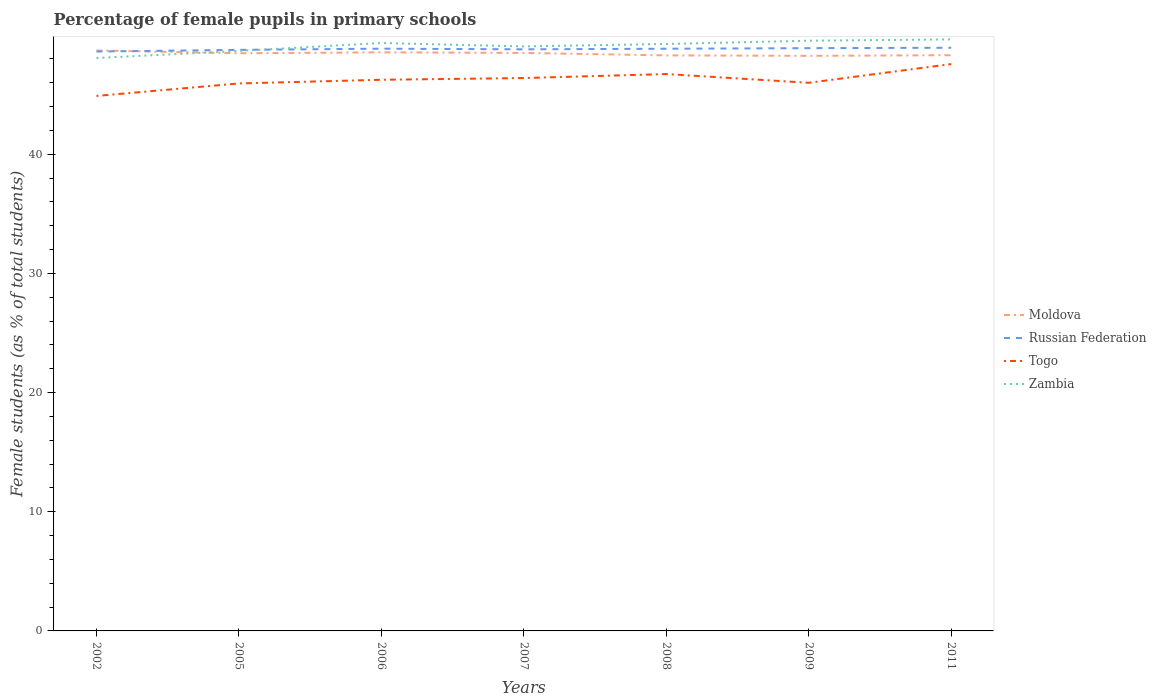Is the number of lines equal to the number of legend labels?
Your answer should be very brief. Yes. Across all years, what is the maximum percentage of female pupils in primary schools in Russian Federation?
Provide a short and direct response. 48.62. What is the total percentage of female pupils in primary schools in Togo in the graph?
Your response must be concise. -1.57. What is the difference between the highest and the second highest percentage of female pupils in primary schools in Zambia?
Ensure brevity in your answer.  1.56. What is the difference between the highest and the lowest percentage of female pupils in primary schools in Zambia?
Ensure brevity in your answer.  4. Is the percentage of female pupils in primary schools in Moldova strictly greater than the percentage of female pupils in primary schools in Russian Federation over the years?
Provide a succinct answer. No. How many years are there in the graph?
Make the answer very short. 7. What is the difference between two consecutive major ticks on the Y-axis?
Provide a succinct answer. 10. Are the values on the major ticks of Y-axis written in scientific E-notation?
Offer a very short reply. No. Does the graph contain any zero values?
Offer a very short reply. No. Does the graph contain grids?
Your answer should be compact. No. Where does the legend appear in the graph?
Keep it short and to the point. Center right. How many legend labels are there?
Your answer should be very brief. 4. What is the title of the graph?
Ensure brevity in your answer.  Percentage of female pupils in primary schools. What is the label or title of the X-axis?
Provide a succinct answer. Years. What is the label or title of the Y-axis?
Your answer should be compact. Female students (as % of total students). What is the Female students (as % of total students) in Moldova in 2002?
Keep it short and to the point. 48.71. What is the Female students (as % of total students) of Russian Federation in 2002?
Provide a short and direct response. 48.62. What is the Female students (as % of total students) in Togo in 2002?
Offer a terse response. 44.89. What is the Female students (as % of total students) of Zambia in 2002?
Give a very brief answer. 48.08. What is the Female students (as % of total students) of Moldova in 2005?
Keep it short and to the point. 48.48. What is the Female students (as % of total students) in Russian Federation in 2005?
Offer a very short reply. 48.76. What is the Female students (as % of total students) of Togo in 2005?
Keep it short and to the point. 45.94. What is the Female students (as % of total students) in Zambia in 2005?
Keep it short and to the point. 48.67. What is the Female students (as % of total students) of Moldova in 2006?
Keep it short and to the point. 48.55. What is the Female students (as % of total students) of Russian Federation in 2006?
Your answer should be compact. 48.86. What is the Female students (as % of total students) of Togo in 2006?
Make the answer very short. 46.25. What is the Female students (as % of total students) in Zambia in 2006?
Your answer should be compact. 49.34. What is the Female students (as % of total students) of Moldova in 2007?
Your answer should be very brief. 48.5. What is the Female students (as % of total students) in Russian Federation in 2007?
Make the answer very short. 48.81. What is the Female students (as % of total students) of Togo in 2007?
Give a very brief answer. 46.4. What is the Female students (as % of total students) in Zambia in 2007?
Your answer should be compact. 49.05. What is the Female students (as % of total students) in Moldova in 2008?
Give a very brief answer. 48.3. What is the Female students (as % of total students) of Russian Federation in 2008?
Ensure brevity in your answer.  48.86. What is the Female students (as % of total students) in Togo in 2008?
Your response must be concise. 46.73. What is the Female students (as % of total students) of Zambia in 2008?
Offer a very short reply. 49.25. What is the Female students (as % of total students) of Moldova in 2009?
Give a very brief answer. 48.26. What is the Female students (as % of total students) of Russian Federation in 2009?
Provide a short and direct response. 48.9. What is the Female students (as % of total students) in Togo in 2009?
Offer a terse response. 46. What is the Female students (as % of total students) of Zambia in 2009?
Your answer should be compact. 49.53. What is the Female students (as % of total students) in Moldova in 2011?
Your response must be concise. 48.31. What is the Female students (as % of total students) of Russian Federation in 2011?
Your answer should be very brief. 48.94. What is the Female students (as % of total students) of Togo in 2011?
Your answer should be very brief. 47.57. What is the Female students (as % of total students) in Zambia in 2011?
Keep it short and to the point. 49.64. Across all years, what is the maximum Female students (as % of total students) in Moldova?
Give a very brief answer. 48.71. Across all years, what is the maximum Female students (as % of total students) in Russian Federation?
Your response must be concise. 48.94. Across all years, what is the maximum Female students (as % of total students) of Togo?
Keep it short and to the point. 47.57. Across all years, what is the maximum Female students (as % of total students) of Zambia?
Your answer should be very brief. 49.64. Across all years, what is the minimum Female students (as % of total students) in Moldova?
Your answer should be very brief. 48.26. Across all years, what is the minimum Female students (as % of total students) of Russian Federation?
Provide a short and direct response. 48.62. Across all years, what is the minimum Female students (as % of total students) of Togo?
Give a very brief answer. 44.89. Across all years, what is the minimum Female students (as % of total students) of Zambia?
Provide a short and direct response. 48.08. What is the total Female students (as % of total students) in Moldova in the graph?
Offer a terse response. 339.11. What is the total Female students (as % of total students) of Russian Federation in the graph?
Your response must be concise. 341.75. What is the total Female students (as % of total students) in Togo in the graph?
Make the answer very short. 323.78. What is the total Female students (as % of total students) of Zambia in the graph?
Your answer should be very brief. 343.56. What is the difference between the Female students (as % of total students) of Moldova in 2002 and that in 2005?
Ensure brevity in your answer.  0.23. What is the difference between the Female students (as % of total students) in Russian Federation in 2002 and that in 2005?
Your response must be concise. -0.14. What is the difference between the Female students (as % of total students) of Togo in 2002 and that in 2005?
Offer a very short reply. -1.05. What is the difference between the Female students (as % of total students) in Zambia in 2002 and that in 2005?
Provide a short and direct response. -0.59. What is the difference between the Female students (as % of total students) of Moldova in 2002 and that in 2006?
Offer a very short reply. 0.16. What is the difference between the Female students (as % of total students) of Russian Federation in 2002 and that in 2006?
Keep it short and to the point. -0.24. What is the difference between the Female students (as % of total students) in Togo in 2002 and that in 2006?
Your answer should be very brief. -1.36. What is the difference between the Female students (as % of total students) of Zambia in 2002 and that in 2006?
Your answer should be compact. -1.26. What is the difference between the Female students (as % of total students) of Moldova in 2002 and that in 2007?
Offer a very short reply. 0.2. What is the difference between the Female students (as % of total students) of Russian Federation in 2002 and that in 2007?
Your answer should be very brief. -0.18. What is the difference between the Female students (as % of total students) of Togo in 2002 and that in 2007?
Your answer should be very brief. -1.5. What is the difference between the Female students (as % of total students) in Zambia in 2002 and that in 2007?
Give a very brief answer. -0.97. What is the difference between the Female students (as % of total students) of Moldova in 2002 and that in 2008?
Provide a short and direct response. 0.41. What is the difference between the Female students (as % of total students) of Russian Federation in 2002 and that in 2008?
Make the answer very short. -0.23. What is the difference between the Female students (as % of total students) of Togo in 2002 and that in 2008?
Offer a terse response. -1.84. What is the difference between the Female students (as % of total students) of Zambia in 2002 and that in 2008?
Ensure brevity in your answer.  -1.18. What is the difference between the Female students (as % of total students) in Moldova in 2002 and that in 2009?
Your answer should be compact. 0.45. What is the difference between the Female students (as % of total students) in Russian Federation in 2002 and that in 2009?
Ensure brevity in your answer.  -0.28. What is the difference between the Female students (as % of total students) of Togo in 2002 and that in 2009?
Provide a succinct answer. -1.1. What is the difference between the Female students (as % of total students) in Zambia in 2002 and that in 2009?
Your response must be concise. -1.45. What is the difference between the Female students (as % of total students) in Moldova in 2002 and that in 2011?
Offer a very short reply. 0.4. What is the difference between the Female students (as % of total students) of Russian Federation in 2002 and that in 2011?
Keep it short and to the point. -0.32. What is the difference between the Female students (as % of total students) in Togo in 2002 and that in 2011?
Keep it short and to the point. -2.68. What is the difference between the Female students (as % of total students) of Zambia in 2002 and that in 2011?
Your response must be concise. -1.56. What is the difference between the Female students (as % of total students) in Moldova in 2005 and that in 2006?
Ensure brevity in your answer.  -0.08. What is the difference between the Female students (as % of total students) of Russian Federation in 2005 and that in 2006?
Give a very brief answer. -0.1. What is the difference between the Female students (as % of total students) of Togo in 2005 and that in 2006?
Ensure brevity in your answer.  -0.31. What is the difference between the Female students (as % of total students) of Zambia in 2005 and that in 2006?
Your answer should be compact. -0.67. What is the difference between the Female students (as % of total students) of Moldova in 2005 and that in 2007?
Provide a succinct answer. -0.03. What is the difference between the Female students (as % of total students) of Russian Federation in 2005 and that in 2007?
Your answer should be very brief. -0.05. What is the difference between the Female students (as % of total students) of Togo in 2005 and that in 2007?
Keep it short and to the point. -0.45. What is the difference between the Female students (as % of total students) of Zambia in 2005 and that in 2007?
Your answer should be very brief. -0.38. What is the difference between the Female students (as % of total students) in Moldova in 2005 and that in 2008?
Keep it short and to the point. 0.18. What is the difference between the Female students (as % of total students) in Russian Federation in 2005 and that in 2008?
Keep it short and to the point. -0.1. What is the difference between the Female students (as % of total students) of Togo in 2005 and that in 2008?
Offer a terse response. -0.79. What is the difference between the Female students (as % of total students) in Zambia in 2005 and that in 2008?
Give a very brief answer. -0.58. What is the difference between the Female students (as % of total students) of Moldova in 2005 and that in 2009?
Give a very brief answer. 0.22. What is the difference between the Female students (as % of total students) in Russian Federation in 2005 and that in 2009?
Make the answer very short. -0.14. What is the difference between the Female students (as % of total students) in Togo in 2005 and that in 2009?
Your response must be concise. -0.06. What is the difference between the Female students (as % of total students) in Zambia in 2005 and that in 2009?
Give a very brief answer. -0.86. What is the difference between the Female students (as % of total students) of Moldova in 2005 and that in 2011?
Your answer should be compact. 0.16. What is the difference between the Female students (as % of total students) in Russian Federation in 2005 and that in 2011?
Offer a very short reply. -0.18. What is the difference between the Female students (as % of total students) of Togo in 2005 and that in 2011?
Your answer should be compact. -1.63. What is the difference between the Female students (as % of total students) in Zambia in 2005 and that in 2011?
Your response must be concise. -0.97. What is the difference between the Female students (as % of total students) in Moldova in 2006 and that in 2007?
Make the answer very short. 0.05. What is the difference between the Female students (as % of total students) of Russian Federation in 2006 and that in 2007?
Keep it short and to the point. 0.06. What is the difference between the Female students (as % of total students) of Togo in 2006 and that in 2007?
Your answer should be compact. -0.14. What is the difference between the Female students (as % of total students) of Zambia in 2006 and that in 2007?
Your response must be concise. 0.29. What is the difference between the Female students (as % of total students) of Moldova in 2006 and that in 2008?
Your answer should be compact. 0.25. What is the difference between the Female students (as % of total students) of Russian Federation in 2006 and that in 2008?
Your answer should be compact. 0.01. What is the difference between the Female students (as % of total students) in Togo in 2006 and that in 2008?
Your answer should be very brief. -0.48. What is the difference between the Female students (as % of total students) of Zambia in 2006 and that in 2008?
Provide a short and direct response. 0.08. What is the difference between the Female students (as % of total students) in Moldova in 2006 and that in 2009?
Offer a very short reply. 0.29. What is the difference between the Female students (as % of total students) in Russian Federation in 2006 and that in 2009?
Make the answer very short. -0.04. What is the difference between the Female students (as % of total students) of Togo in 2006 and that in 2009?
Provide a short and direct response. 0.25. What is the difference between the Female students (as % of total students) of Zambia in 2006 and that in 2009?
Ensure brevity in your answer.  -0.19. What is the difference between the Female students (as % of total students) in Moldova in 2006 and that in 2011?
Make the answer very short. 0.24. What is the difference between the Female students (as % of total students) of Russian Federation in 2006 and that in 2011?
Keep it short and to the point. -0.08. What is the difference between the Female students (as % of total students) of Togo in 2006 and that in 2011?
Your response must be concise. -1.32. What is the difference between the Female students (as % of total students) in Zambia in 2006 and that in 2011?
Offer a very short reply. -0.3. What is the difference between the Female students (as % of total students) in Moldova in 2007 and that in 2008?
Offer a terse response. 0.21. What is the difference between the Female students (as % of total students) in Russian Federation in 2007 and that in 2008?
Offer a terse response. -0.05. What is the difference between the Female students (as % of total students) of Togo in 2007 and that in 2008?
Give a very brief answer. -0.33. What is the difference between the Female students (as % of total students) of Zambia in 2007 and that in 2008?
Provide a short and direct response. -0.2. What is the difference between the Female students (as % of total students) in Moldova in 2007 and that in 2009?
Provide a succinct answer. 0.24. What is the difference between the Female students (as % of total students) in Russian Federation in 2007 and that in 2009?
Give a very brief answer. -0.1. What is the difference between the Female students (as % of total students) of Togo in 2007 and that in 2009?
Keep it short and to the point. 0.4. What is the difference between the Female students (as % of total students) of Zambia in 2007 and that in 2009?
Give a very brief answer. -0.48. What is the difference between the Female students (as % of total students) of Moldova in 2007 and that in 2011?
Your answer should be compact. 0.19. What is the difference between the Female students (as % of total students) of Russian Federation in 2007 and that in 2011?
Provide a short and direct response. -0.13. What is the difference between the Female students (as % of total students) of Togo in 2007 and that in 2011?
Your answer should be compact. -1.17. What is the difference between the Female students (as % of total students) of Zambia in 2007 and that in 2011?
Provide a succinct answer. -0.59. What is the difference between the Female students (as % of total students) of Moldova in 2008 and that in 2009?
Provide a short and direct response. 0.04. What is the difference between the Female students (as % of total students) in Russian Federation in 2008 and that in 2009?
Your answer should be compact. -0.05. What is the difference between the Female students (as % of total students) of Togo in 2008 and that in 2009?
Provide a succinct answer. 0.73. What is the difference between the Female students (as % of total students) in Zambia in 2008 and that in 2009?
Provide a short and direct response. -0.28. What is the difference between the Female students (as % of total students) of Moldova in 2008 and that in 2011?
Ensure brevity in your answer.  -0.01. What is the difference between the Female students (as % of total students) in Russian Federation in 2008 and that in 2011?
Your answer should be very brief. -0.08. What is the difference between the Female students (as % of total students) of Togo in 2008 and that in 2011?
Give a very brief answer. -0.84. What is the difference between the Female students (as % of total students) of Zambia in 2008 and that in 2011?
Offer a very short reply. -0.39. What is the difference between the Female students (as % of total students) in Moldova in 2009 and that in 2011?
Your answer should be very brief. -0.05. What is the difference between the Female students (as % of total students) in Russian Federation in 2009 and that in 2011?
Offer a very short reply. -0.03. What is the difference between the Female students (as % of total students) of Togo in 2009 and that in 2011?
Ensure brevity in your answer.  -1.57. What is the difference between the Female students (as % of total students) in Zambia in 2009 and that in 2011?
Provide a short and direct response. -0.11. What is the difference between the Female students (as % of total students) in Moldova in 2002 and the Female students (as % of total students) in Russian Federation in 2005?
Make the answer very short. -0.05. What is the difference between the Female students (as % of total students) of Moldova in 2002 and the Female students (as % of total students) of Togo in 2005?
Ensure brevity in your answer.  2.77. What is the difference between the Female students (as % of total students) of Moldova in 2002 and the Female students (as % of total students) of Zambia in 2005?
Ensure brevity in your answer.  0.04. What is the difference between the Female students (as % of total students) of Russian Federation in 2002 and the Female students (as % of total students) of Togo in 2005?
Ensure brevity in your answer.  2.68. What is the difference between the Female students (as % of total students) in Russian Federation in 2002 and the Female students (as % of total students) in Zambia in 2005?
Provide a succinct answer. -0.05. What is the difference between the Female students (as % of total students) of Togo in 2002 and the Female students (as % of total students) of Zambia in 2005?
Make the answer very short. -3.78. What is the difference between the Female students (as % of total students) in Moldova in 2002 and the Female students (as % of total students) in Russian Federation in 2006?
Your answer should be compact. -0.15. What is the difference between the Female students (as % of total students) of Moldova in 2002 and the Female students (as % of total students) of Togo in 2006?
Your answer should be compact. 2.46. What is the difference between the Female students (as % of total students) in Moldova in 2002 and the Female students (as % of total students) in Zambia in 2006?
Provide a short and direct response. -0.63. What is the difference between the Female students (as % of total students) of Russian Federation in 2002 and the Female students (as % of total students) of Togo in 2006?
Make the answer very short. 2.37. What is the difference between the Female students (as % of total students) in Russian Federation in 2002 and the Female students (as % of total students) in Zambia in 2006?
Give a very brief answer. -0.72. What is the difference between the Female students (as % of total students) in Togo in 2002 and the Female students (as % of total students) in Zambia in 2006?
Ensure brevity in your answer.  -4.44. What is the difference between the Female students (as % of total students) of Moldova in 2002 and the Female students (as % of total students) of Russian Federation in 2007?
Provide a short and direct response. -0.1. What is the difference between the Female students (as % of total students) of Moldova in 2002 and the Female students (as % of total students) of Togo in 2007?
Provide a succinct answer. 2.31. What is the difference between the Female students (as % of total students) in Moldova in 2002 and the Female students (as % of total students) in Zambia in 2007?
Your answer should be very brief. -0.34. What is the difference between the Female students (as % of total students) of Russian Federation in 2002 and the Female students (as % of total students) of Togo in 2007?
Your response must be concise. 2.23. What is the difference between the Female students (as % of total students) of Russian Federation in 2002 and the Female students (as % of total students) of Zambia in 2007?
Give a very brief answer. -0.43. What is the difference between the Female students (as % of total students) of Togo in 2002 and the Female students (as % of total students) of Zambia in 2007?
Give a very brief answer. -4.16. What is the difference between the Female students (as % of total students) in Moldova in 2002 and the Female students (as % of total students) in Russian Federation in 2008?
Your answer should be compact. -0.15. What is the difference between the Female students (as % of total students) in Moldova in 2002 and the Female students (as % of total students) in Togo in 2008?
Your answer should be very brief. 1.98. What is the difference between the Female students (as % of total students) in Moldova in 2002 and the Female students (as % of total students) in Zambia in 2008?
Offer a very short reply. -0.54. What is the difference between the Female students (as % of total students) in Russian Federation in 2002 and the Female students (as % of total students) in Togo in 2008?
Give a very brief answer. 1.89. What is the difference between the Female students (as % of total students) in Russian Federation in 2002 and the Female students (as % of total students) in Zambia in 2008?
Offer a terse response. -0.63. What is the difference between the Female students (as % of total students) in Togo in 2002 and the Female students (as % of total students) in Zambia in 2008?
Offer a terse response. -4.36. What is the difference between the Female students (as % of total students) of Moldova in 2002 and the Female students (as % of total students) of Russian Federation in 2009?
Make the answer very short. -0.2. What is the difference between the Female students (as % of total students) of Moldova in 2002 and the Female students (as % of total students) of Togo in 2009?
Provide a short and direct response. 2.71. What is the difference between the Female students (as % of total students) in Moldova in 2002 and the Female students (as % of total students) in Zambia in 2009?
Offer a terse response. -0.82. What is the difference between the Female students (as % of total students) in Russian Federation in 2002 and the Female students (as % of total students) in Togo in 2009?
Ensure brevity in your answer.  2.62. What is the difference between the Female students (as % of total students) in Russian Federation in 2002 and the Female students (as % of total students) in Zambia in 2009?
Make the answer very short. -0.91. What is the difference between the Female students (as % of total students) in Togo in 2002 and the Female students (as % of total students) in Zambia in 2009?
Offer a terse response. -4.64. What is the difference between the Female students (as % of total students) of Moldova in 2002 and the Female students (as % of total students) of Russian Federation in 2011?
Keep it short and to the point. -0.23. What is the difference between the Female students (as % of total students) of Moldova in 2002 and the Female students (as % of total students) of Togo in 2011?
Make the answer very short. 1.14. What is the difference between the Female students (as % of total students) in Moldova in 2002 and the Female students (as % of total students) in Zambia in 2011?
Ensure brevity in your answer.  -0.93. What is the difference between the Female students (as % of total students) in Russian Federation in 2002 and the Female students (as % of total students) in Togo in 2011?
Your response must be concise. 1.05. What is the difference between the Female students (as % of total students) in Russian Federation in 2002 and the Female students (as % of total students) in Zambia in 2011?
Your answer should be very brief. -1.02. What is the difference between the Female students (as % of total students) in Togo in 2002 and the Female students (as % of total students) in Zambia in 2011?
Provide a succinct answer. -4.75. What is the difference between the Female students (as % of total students) in Moldova in 2005 and the Female students (as % of total students) in Russian Federation in 2006?
Provide a succinct answer. -0.39. What is the difference between the Female students (as % of total students) of Moldova in 2005 and the Female students (as % of total students) of Togo in 2006?
Provide a succinct answer. 2.22. What is the difference between the Female students (as % of total students) in Moldova in 2005 and the Female students (as % of total students) in Zambia in 2006?
Provide a succinct answer. -0.86. What is the difference between the Female students (as % of total students) of Russian Federation in 2005 and the Female students (as % of total students) of Togo in 2006?
Your answer should be compact. 2.51. What is the difference between the Female students (as % of total students) in Russian Federation in 2005 and the Female students (as % of total students) in Zambia in 2006?
Give a very brief answer. -0.58. What is the difference between the Female students (as % of total students) in Togo in 2005 and the Female students (as % of total students) in Zambia in 2006?
Provide a succinct answer. -3.39. What is the difference between the Female students (as % of total students) in Moldova in 2005 and the Female students (as % of total students) in Russian Federation in 2007?
Offer a very short reply. -0.33. What is the difference between the Female students (as % of total students) of Moldova in 2005 and the Female students (as % of total students) of Togo in 2007?
Provide a short and direct response. 2.08. What is the difference between the Female students (as % of total students) in Moldova in 2005 and the Female students (as % of total students) in Zambia in 2007?
Your answer should be compact. -0.57. What is the difference between the Female students (as % of total students) of Russian Federation in 2005 and the Female students (as % of total students) of Togo in 2007?
Give a very brief answer. 2.36. What is the difference between the Female students (as % of total students) in Russian Federation in 2005 and the Female students (as % of total students) in Zambia in 2007?
Provide a succinct answer. -0.29. What is the difference between the Female students (as % of total students) in Togo in 2005 and the Female students (as % of total students) in Zambia in 2007?
Give a very brief answer. -3.11. What is the difference between the Female students (as % of total students) in Moldova in 2005 and the Female students (as % of total students) in Russian Federation in 2008?
Give a very brief answer. -0.38. What is the difference between the Female students (as % of total students) of Moldova in 2005 and the Female students (as % of total students) of Togo in 2008?
Your answer should be compact. 1.75. What is the difference between the Female students (as % of total students) of Moldova in 2005 and the Female students (as % of total students) of Zambia in 2008?
Make the answer very short. -0.78. What is the difference between the Female students (as % of total students) in Russian Federation in 2005 and the Female students (as % of total students) in Togo in 2008?
Offer a very short reply. 2.03. What is the difference between the Female students (as % of total students) in Russian Federation in 2005 and the Female students (as % of total students) in Zambia in 2008?
Offer a terse response. -0.49. What is the difference between the Female students (as % of total students) in Togo in 2005 and the Female students (as % of total students) in Zambia in 2008?
Give a very brief answer. -3.31. What is the difference between the Female students (as % of total students) in Moldova in 2005 and the Female students (as % of total students) in Russian Federation in 2009?
Your answer should be very brief. -0.43. What is the difference between the Female students (as % of total students) in Moldova in 2005 and the Female students (as % of total students) in Togo in 2009?
Ensure brevity in your answer.  2.48. What is the difference between the Female students (as % of total students) in Moldova in 2005 and the Female students (as % of total students) in Zambia in 2009?
Your answer should be very brief. -1.05. What is the difference between the Female students (as % of total students) of Russian Federation in 2005 and the Female students (as % of total students) of Togo in 2009?
Make the answer very short. 2.76. What is the difference between the Female students (as % of total students) of Russian Federation in 2005 and the Female students (as % of total students) of Zambia in 2009?
Offer a very short reply. -0.77. What is the difference between the Female students (as % of total students) in Togo in 2005 and the Female students (as % of total students) in Zambia in 2009?
Offer a very short reply. -3.59. What is the difference between the Female students (as % of total students) in Moldova in 2005 and the Female students (as % of total students) in Russian Federation in 2011?
Your answer should be compact. -0.46. What is the difference between the Female students (as % of total students) in Moldova in 2005 and the Female students (as % of total students) in Togo in 2011?
Provide a succinct answer. 0.91. What is the difference between the Female students (as % of total students) in Moldova in 2005 and the Female students (as % of total students) in Zambia in 2011?
Keep it short and to the point. -1.16. What is the difference between the Female students (as % of total students) in Russian Federation in 2005 and the Female students (as % of total students) in Togo in 2011?
Keep it short and to the point. 1.19. What is the difference between the Female students (as % of total students) in Russian Federation in 2005 and the Female students (as % of total students) in Zambia in 2011?
Your answer should be very brief. -0.88. What is the difference between the Female students (as % of total students) of Togo in 2005 and the Female students (as % of total students) of Zambia in 2011?
Offer a very short reply. -3.7. What is the difference between the Female students (as % of total students) of Moldova in 2006 and the Female students (as % of total students) of Russian Federation in 2007?
Keep it short and to the point. -0.25. What is the difference between the Female students (as % of total students) of Moldova in 2006 and the Female students (as % of total students) of Togo in 2007?
Your answer should be compact. 2.16. What is the difference between the Female students (as % of total students) of Moldova in 2006 and the Female students (as % of total students) of Zambia in 2007?
Ensure brevity in your answer.  -0.5. What is the difference between the Female students (as % of total students) of Russian Federation in 2006 and the Female students (as % of total students) of Togo in 2007?
Provide a short and direct response. 2.47. What is the difference between the Female students (as % of total students) of Russian Federation in 2006 and the Female students (as % of total students) of Zambia in 2007?
Offer a terse response. -0.19. What is the difference between the Female students (as % of total students) of Togo in 2006 and the Female students (as % of total students) of Zambia in 2007?
Make the answer very short. -2.8. What is the difference between the Female students (as % of total students) of Moldova in 2006 and the Female students (as % of total students) of Russian Federation in 2008?
Provide a short and direct response. -0.3. What is the difference between the Female students (as % of total students) in Moldova in 2006 and the Female students (as % of total students) in Togo in 2008?
Provide a short and direct response. 1.82. What is the difference between the Female students (as % of total students) in Moldova in 2006 and the Female students (as % of total students) in Zambia in 2008?
Keep it short and to the point. -0.7. What is the difference between the Female students (as % of total students) of Russian Federation in 2006 and the Female students (as % of total students) of Togo in 2008?
Give a very brief answer. 2.13. What is the difference between the Female students (as % of total students) in Russian Federation in 2006 and the Female students (as % of total students) in Zambia in 2008?
Keep it short and to the point. -0.39. What is the difference between the Female students (as % of total students) of Togo in 2006 and the Female students (as % of total students) of Zambia in 2008?
Your answer should be compact. -3. What is the difference between the Female students (as % of total students) in Moldova in 2006 and the Female students (as % of total students) in Russian Federation in 2009?
Keep it short and to the point. -0.35. What is the difference between the Female students (as % of total students) of Moldova in 2006 and the Female students (as % of total students) of Togo in 2009?
Your answer should be compact. 2.55. What is the difference between the Female students (as % of total students) in Moldova in 2006 and the Female students (as % of total students) in Zambia in 2009?
Offer a very short reply. -0.98. What is the difference between the Female students (as % of total students) in Russian Federation in 2006 and the Female students (as % of total students) in Togo in 2009?
Provide a succinct answer. 2.86. What is the difference between the Female students (as % of total students) in Russian Federation in 2006 and the Female students (as % of total students) in Zambia in 2009?
Provide a short and direct response. -0.67. What is the difference between the Female students (as % of total students) of Togo in 2006 and the Female students (as % of total students) of Zambia in 2009?
Keep it short and to the point. -3.28. What is the difference between the Female students (as % of total students) of Moldova in 2006 and the Female students (as % of total students) of Russian Federation in 2011?
Ensure brevity in your answer.  -0.39. What is the difference between the Female students (as % of total students) of Moldova in 2006 and the Female students (as % of total students) of Togo in 2011?
Offer a terse response. 0.98. What is the difference between the Female students (as % of total students) of Moldova in 2006 and the Female students (as % of total students) of Zambia in 2011?
Keep it short and to the point. -1.09. What is the difference between the Female students (as % of total students) of Russian Federation in 2006 and the Female students (as % of total students) of Togo in 2011?
Offer a very short reply. 1.29. What is the difference between the Female students (as % of total students) of Russian Federation in 2006 and the Female students (as % of total students) of Zambia in 2011?
Your answer should be very brief. -0.78. What is the difference between the Female students (as % of total students) of Togo in 2006 and the Female students (as % of total students) of Zambia in 2011?
Your answer should be very brief. -3.39. What is the difference between the Female students (as % of total students) of Moldova in 2007 and the Female students (as % of total students) of Russian Federation in 2008?
Provide a succinct answer. -0.35. What is the difference between the Female students (as % of total students) in Moldova in 2007 and the Female students (as % of total students) in Togo in 2008?
Offer a very short reply. 1.77. What is the difference between the Female students (as % of total students) of Moldova in 2007 and the Female students (as % of total students) of Zambia in 2008?
Your answer should be compact. -0.75. What is the difference between the Female students (as % of total students) in Russian Federation in 2007 and the Female students (as % of total students) in Togo in 2008?
Give a very brief answer. 2.07. What is the difference between the Female students (as % of total students) in Russian Federation in 2007 and the Female students (as % of total students) in Zambia in 2008?
Your answer should be very brief. -0.45. What is the difference between the Female students (as % of total students) in Togo in 2007 and the Female students (as % of total students) in Zambia in 2008?
Your answer should be compact. -2.86. What is the difference between the Female students (as % of total students) of Moldova in 2007 and the Female students (as % of total students) of Russian Federation in 2009?
Your answer should be compact. -0.4. What is the difference between the Female students (as % of total students) of Moldova in 2007 and the Female students (as % of total students) of Togo in 2009?
Your answer should be compact. 2.51. What is the difference between the Female students (as % of total students) in Moldova in 2007 and the Female students (as % of total students) in Zambia in 2009?
Offer a terse response. -1.02. What is the difference between the Female students (as % of total students) in Russian Federation in 2007 and the Female students (as % of total students) in Togo in 2009?
Give a very brief answer. 2.81. What is the difference between the Female students (as % of total students) of Russian Federation in 2007 and the Female students (as % of total students) of Zambia in 2009?
Keep it short and to the point. -0.72. What is the difference between the Female students (as % of total students) of Togo in 2007 and the Female students (as % of total students) of Zambia in 2009?
Your answer should be compact. -3.13. What is the difference between the Female students (as % of total students) of Moldova in 2007 and the Female students (as % of total students) of Russian Federation in 2011?
Ensure brevity in your answer.  -0.43. What is the difference between the Female students (as % of total students) in Moldova in 2007 and the Female students (as % of total students) in Togo in 2011?
Keep it short and to the point. 0.94. What is the difference between the Female students (as % of total students) in Moldova in 2007 and the Female students (as % of total students) in Zambia in 2011?
Offer a terse response. -1.13. What is the difference between the Female students (as % of total students) of Russian Federation in 2007 and the Female students (as % of total students) of Togo in 2011?
Your answer should be compact. 1.24. What is the difference between the Female students (as % of total students) in Russian Federation in 2007 and the Female students (as % of total students) in Zambia in 2011?
Keep it short and to the point. -0.83. What is the difference between the Female students (as % of total students) of Togo in 2007 and the Female students (as % of total students) of Zambia in 2011?
Your answer should be compact. -3.24. What is the difference between the Female students (as % of total students) in Moldova in 2008 and the Female students (as % of total students) in Russian Federation in 2009?
Provide a succinct answer. -0.61. What is the difference between the Female students (as % of total students) of Moldova in 2008 and the Female students (as % of total students) of Togo in 2009?
Keep it short and to the point. 2.3. What is the difference between the Female students (as % of total students) in Moldova in 2008 and the Female students (as % of total students) in Zambia in 2009?
Your response must be concise. -1.23. What is the difference between the Female students (as % of total students) of Russian Federation in 2008 and the Female students (as % of total students) of Togo in 2009?
Your answer should be compact. 2.86. What is the difference between the Female students (as % of total students) of Russian Federation in 2008 and the Female students (as % of total students) of Zambia in 2009?
Provide a succinct answer. -0.67. What is the difference between the Female students (as % of total students) in Togo in 2008 and the Female students (as % of total students) in Zambia in 2009?
Your answer should be compact. -2.8. What is the difference between the Female students (as % of total students) in Moldova in 2008 and the Female students (as % of total students) in Russian Federation in 2011?
Offer a terse response. -0.64. What is the difference between the Female students (as % of total students) of Moldova in 2008 and the Female students (as % of total students) of Togo in 2011?
Ensure brevity in your answer.  0.73. What is the difference between the Female students (as % of total students) of Moldova in 2008 and the Female students (as % of total students) of Zambia in 2011?
Provide a short and direct response. -1.34. What is the difference between the Female students (as % of total students) of Russian Federation in 2008 and the Female students (as % of total students) of Togo in 2011?
Your response must be concise. 1.29. What is the difference between the Female students (as % of total students) of Russian Federation in 2008 and the Female students (as % of total students) of Zambia in 2011?
Your answer should be compact. -0.78. What is the difference between the Female students (as % of total students) of Togo in 2008 and the Female students (as % of total students) of Zambia in 2011?
Provide a succinct answer. -2.91. What is the difference between the Female students (as % of total students) in Moldova in 2009 and the Female students (as % of total students) in Russian Federation in 2011?
Keep it short and to the point. -0.68. What is the difference between the Female students (as % of total students) in Moldova in 2009 and the Female students (as % of total students) in Togo in 2011?
Offer a very short reply. 0.69. What is the difference between the Female students (as % of total students) of Moldova in 2009 and the Female students (as % of total students) of Zambia in 2011?
Offer a terse response. -1.38. What is the difference between the Female students (as % of total students) of Russian Federation in 2009 and the Female students (as % of total students) of Togo in 2011?
Offer a terse response. 1.34. What is the difference between the Female students (as % of total students) of Russian Federation in 2009 and the Female students (as % of total students) of Zambia in 2011?
Provide a short and direct response. -0.73. What is the difference between the Female students (as % of total students) of Togo in 2009 and the Female students (as % of total students) of Zambia in 2011?
Keep it short and to the point. -3.64. What is the average Female students (as % of total students) in Moldova per year?
Your response must be concise. 48.44. What is the average Female students (as % of total students) of Russian Federation per year?
Your response must be concise. 48.82. What is the average Female students (as % of total students) in Togo per year?
Make the answer very short. 46.25. What is the average Female students (as % of total students) of Zambia per year?
Provide a succinct answer. 49.08. In the year 2002, what is the difference between the Female students (as % of total students) in Moldova and Female students (as % of total students) in Russian Federation?
Keep it short and to the point. 0.09. In the year 2002, what is the difference between the Female students (as % of total students) in Moldova and Female students (as % of total students) in Togo?
Ensure brevity in your answer.  3.82. In the year 2002, what is the difference between the Female students (as % of total students) of Moldova and Female students (as % of total students) of Zambia?
Offer a terse response. 0.63. In the year 2002, what is the difference between the Female students (as % of total students) in Russian Federation and Female students (as % of total students) in Togo?
Your answer should be very brief. 3.73. In the year 2002, what is the difference between the Female students (as % of total students) of Russian Federation and Female students (as % of total students) of Zambia?
Provide a succinct answer. 0.55. In the year 2002, what is the difference between the Female students (as % of total students) of Togo and Female students (as % of total students) of Zambia?
Your answer should be very brief. -3.18. In the year 2005, what is the difference between the Female students (as % of total students) of Moldova and Female students (as % of total students) of Russian Federation?
Ensure brevity in your answer.  -0.28. In the year 2005, what is the difference between the Female students (as % of total students) of Moldova and Female students (as % of total students) of Togo?
Offer a terse response. 2.53. In the year 2005, what is the difference between the Female students (as % of total students) in Moldova and Female students (as % of total students) in Zambia?
Give a very brief answer. -0.19. In the year 2005, what is the difference between the Female students (as % of total students) of Russian Federation and Female students (as % of total students) of Togo?
Keep it short and to the point. 2.82. In the year 2005, what is the difference between the Female students (as % of total students) in Russian Federation and Female students (as % of total students) in Zambia?
Your answer should be compact. 0.09. In the year 2005, what is the difference between the Female students (as % of total students) in Togo and Female students (as % of total students) in Zambia?
Provide a succinct answer. -2.73. In the year 2006, what is the difference between the Female students (as % of total students) of Moldova and Female students (as % of total students) of Russian Federation?
Ensure brevity in your answer.  -0.31. In the year 2006, what is the difference between the Female students (as % of total students) of Moldova and Female students (as % of total students) of Togo?
Offer a very short reply. 2.3. In the year 2006, what is the difference between the Female students (as % of total students) in Moldova and Female students (as % of total students) in Zambia?
Offer a terse response. -0.79. In the year 2006, what is the difference between the Female students (as % of total students) in Russian Federation and Female students (as % of total students) in Togo?
Provide a succinct answer. 2.61. In the year 2006, what is the difference between the Female students (as % of total students) in Russian Federation and Female students (as % of total students) in Zambia?
Your answer should be compact. -0.47. In the year 2006, what is the difference between the Female students (as % of total students) in Togo and Female students (as % of total students) in Zambia?
Ensure brevity in your answer.  -3.09. In the year 2007, what is the difference between the Female students (as % of total students) of Moldova and Female students (as % of total students) of Russian Federation?
Your response must be concise. -0.3. In the year 2007, what is the difference between the Female students (as % of total students) of Moldova and Female students (as % of total students) of Togo?
Give a very brief answer. 2.11. In the year 2007, what is the difference between the Female students (as % of total students) in Moldova and Female students (as % of total students) in Zambia?
Offer a terse response. -0.55. In the year 2007, what is the difference between the Female students (as % of total students) in Russian Federation and Female students (as % of total students) in Togo?
Keep it short and to the point. 2.41. In the year 2007, what is the difference between the Female students (as % of total students) of Russian Federation and Female students (as % of total students) of Zambia?
Offer a terse response. -0.24. In the year 2007, what is the difference between the Female students (as % of total students) in Togo and Female students (as % of total students) in Zambia?
Ensure brevity in your answer.  -2.65. In the year 2008, what is the difference between the Female students (as % of total students) of Moldova and Female students (as % of total students) of Russian Federation?
Offer a terse response. -0.56. In the year 2008, what is the difference between the Female students (as % of total students) in Moldova and Female students (as % of total students) in Togo?
Make the answer very short. 1.57. In the year 2008, what is the difference between the Female students (as % of total students) in Moldova and Female students (as % of total students) in Zambia?
Offer a terse response. -0.95. In the year 2008, what is the difference between the Female students (as % of total students) of Russian Federation and Female students (as % of total students) of Togo?
Your response must be concise. 2.13. In the year 2008, what is the difference between the Female students (as % of total students) in Russian Federation and Female students (as % of total students) in Zambia?
Your answer should be very brief. -0.4. In the year 2008, what is the difference between the Female students (as % of total students) of Togo and Female students (as % of total students) of Zambia?
Your answer should be compact. -2.52. In the year 2009, what is the difference between the Female students (as % of total students) of Moldova and Female students (as % of total students) of Russian Federation?
Offer a very short reply. -0.64. In the year 2009, what is the difference between the Female students (as % of total students) of Moldova and Female students (as % of total students) of Togo?
Provide a succinct answer. 2.26. In the year 2009, what is the difference between the Female students (as % of total students) of Moldova and Female students (as % of total students) of Zambia?
Ensure brevity in your answer.  -1.27. In the year 2009, what is the difference between the Female students (as % of total students) in Russian Federation and Female students (as % of total students) in Togo?
Your answer should be very brief. 2.91. In the year 2009, what is the difference between the Female students (as % of total students) in Russian Federation and Female students (as % of total students) in Zambia?
Provide a succinct answer. -0.62. In the year 2009, what is the difference between the Female students (as % of total students) of Togo and Female students (as % of total students) of Zambia?
Keep it short and to the point. -3.53. In the year 2011, what is the difference between the Female students (as % of total students) of Moldova and Female students (as % of total students) of Russian Federation?
Keep it short and to the point. -0.62. In the year 2011, what is the difference between the Female students (as % of total students) in Moldova and Female students (as % of total students) in Togo?
Provide a short and direct response. 0.74. In the year 2011, what is the difference between the Female students (as % of total students) of Moldova and Female students (as % of total students) of Zambia?
Offer a very short reply. -1.33. In the year 2011, what is the difference between the Female students (as % of total students) in Russian Federation and Female students (as % of total students) in Togo?
Offer a very short reply. 1.37. In the year 2011, what is the difference between the Female students (as % of total students) in Russian Federation and Female students (as % of total students) in Zambia?
Make the answer very short. -0.7. In the year 2011, what is the difference between the Female students (as % of total students) in Togo and Female students (as % of total students) in Zambia?
Give a very brief answer. -2.07. What is the ratio of the Female students (as % of total students) in Russian Federation in 2002 to that in 2005?
Your answer should be very brief. 1. What is the ratio of the Female students (as % of total students) in Togo in 2002 to that in 2005?
Offer a very short reply. 0.98. What is the ratio of the Female students (as % of total students) in Zambia in 2002 to that in 2005?
Offer a terse response. 0.99. What is the ratio of the Female students (as % of total students) of Togo in 2002 to that in 2006?
Your response must be concise. 0.97. What is the ratio of the Female students (as % of total students) of Zambia in 2002 to that in 2006?
Make the answer very short. 0.97. What is the ratio of the Female students (as % of total students) of Russian Federation in 2002 to that in 2007?
Provide a short and direct response. 1. What is the ratio of the Female students (as % of total students) in Togo in 2002 to that in 2007?
Ensure brevity in your answer.  0.97. What is the ratio of the Female students (as % of total students) of Zambia in 2002 to that in 2007?
Give a very brief answer. 0.98. What is the ratio of the Female students (as % of total students) of Moldova in 2002 to that in 2008?
Provide a succinct answer. 1.01. What is the ratio of the Female students (as % of total students) in Togo in 2002 to that in 2008?
Your answer should be compact. 0.96. What is the ratio of the Female students (as % of total students) in Zambia in 2002 to that in 2008?
Provide a succinct answer. 0.98. What is the ratio of the Female students (as % of total students) of Moldova in 2002 to that in 2009?
Make the answer very short. 1.01. What is the ratio of the Female students (as % of total students) in Zambia in 2002 to that in 2009?
Your answer should be compact. 0.97. What is the ratio of the Female students (as % of total students) of Moldova in 2002 to that in 2011?
Offer a terse response. 1.01. What is the ratio of the Female students (as % of total students) of Togo in 2002 to that in 2011?
Offer a very short reply. 0.94. What is the ratio of the Female students (as % of total students) of Zambia in 2002 to that in 2011?
Give a very brief answer. 0.97. What is the ratio of the Female students (as % of total students) in Russian Federation in 2005 to that in 2006?
Your answer should be compact. 1. What is the ratio of the Female students (as % of total students) of Togo in 2005 to that in 2006?
Your response must be concise. 0.99. What is the ratio of the Female students (as % of total students) in Zambia in 2005 to that in 2006?
Give a very brief answer. 0.99. What is the ratio of the Female students (as % of total students) in Togo in 2005 to that in 2007?
Your response must be concise. 0.99. What is the ratio of the Female students (as % of total students) in Zambia in 2005 to that in 2007?
Your answer should be compact. 0.99. What is the ratio of the Female students (as % of total students) in Moldova in 2005 to that in 2008?
Keep it short and to the point. 1. What is the ratio of the Female students (as % of total students) in Russian Federation in 2005 to that in 2008?
Make the answer very short. 1. What is the ratio of the Female students (as % of total students) of Togo in 2005 to that in 2008?
Keep it short and to the point. 0.98. What is the ratio of the Female students (as % of total students) in Zambia in 2005 to that in 2008?
Provide a short and direct response. 0.99. What is the ratio of the Female students (as % of total students) in Moldova in 2005 to that in 2009?
Ensure brevity in your answer.  1. What is the ratio of the Female students (as % of total students) of Russian Federation in 2005 to that in 2009?
Your answer should be compact. 1. What is the ratio of the Female students (as % of total students) in Zambia in 2005 to that in 2009?
Offer a terse response. 0.98. What is the ratio of the Female students (as % of total students) in Russian Federation in 2005 to that in 2011?
Keep it short and to the point. 1. What is the ratio of the Female students (as % of total students) in Togo in 2005 to that in 2011?
Offer a very short reply. 0.97. What is the ratio of the Female students (as % of total students) in Zambia in 2005 to that in 2011?
Make the answer very short. 0.98. What is the ratio of the Female students (as % of total students) in Moldova in 2006 to that in 2007?
Offer a very short reply. 1. What is the ratio of the Female students (as % of total students) in Russian Federation in 2006 to that in 2007?
Keep it short and to the point. 1. What is the ratio of the Female students (as % of total students) in Zambia in 2006 to that in 2007?
Your response must be concise. 1.01. What is the ratio of the Female students (as % of total students) of Moldova in 2006 to that in 2008?
Make the answer very short. 1.01. What is the ratio of the Female students (as % of total students) of Togo in 2006 to that in 2008?
Give a very brief answer. 0.99. What is the ratio of the Female students (as % of total students) of Togo in 2006 to that in 2009?
Offer a terse response. 1.01. What is the ratio of the Female students (as % of total students) in Zambia in 2006 to that in 2009?
Make the answer very short. 1. What is the ratio of the Female students (as % of total students) of Moldova in 2006 to that in 2011?
Offer a terse response. 1. What is the ratio of the Female students (as % of total students) of Russian Federation in 2006 to that in 2011?
Provide a short and direct response. 1. What is the ratio of the Female students (as % of total students) of Togo in 2006 to that in 2011?
Keep it short and to the point. 0.97. What is the ratio of the Female students (as % of total students) of Zambia in 2006 to that in 2011?
Make the answer very short. 0.99. What is the ratio of the Female students (as % of total students) in Togo in 2007 to that in 2008?
Ensure brevity in your answer.  0.99. What is the ratio of the Female students (as % of total students) of Russian Federation in 2007 to that in 2009?
Your answer should be very brief. 1. What is the ratio of the Female students (as % of total students) of Togo in 2007 to that in 2009?
Provide a short and direct response. 1.01. What is the ratio of the Female students (as % of total students) in Zambia in 2007 to that in 2009?
Your answer should be compact. 0.99. What is the ratio of the Female students (as % of total students) in Togo in 2007 to that in 2011?
Provide a succinct answer. 0.98. What is the ratio of the Female students (as % of total students) of Moldova in 2008 to that in 2009?
Make the answer very short. 1. What is the ratio of the Female students (as % of total students) in Togo in 2008 to that in 2009?
Offer a terse response. 1.02. What is the ratio of the Female students (as % of total students) of Zambia in 2008 to that in 2009?
Your answer should be compact. 0.99. What is the ratio of the Female students (as % of total students) of Moldova in 2008 to that in 2011?
Provide a short and direct response. 1. What is the ratio of the Female students (as % of total students) of Togo in 2008 to that in 2011?
Offer a very short reply. 0.98. What is the ratio of the Female students (as % of total students) in Moldova in 2009 to that in 2011?
Offer a very short reply. 1. What is the ratio of the Female students (as % of total students) in Russian Federation in 2009 to that in 2011?
Keep it short and to the point. 1. What is the ratio of the Female students (as % of total students) in Zambia in 2009 to that in 2011?
Your answer should be compact. 1. What is the difference between the highest and the second highest Female students (as % of total students) in Moldova?
Your answer should be compact. 0.16. What is the difference between the highest and the second highest Female students (as % of total students) in Russian Federation?
Offer a very short reply. 0.03. What is the difference between the highest and the second highest Female students (as % of total students) of Togo?
Provide a succinct answer. 0.84. What is the difference between the highest and the second highest Female students (as % of total students) in Zambia?
Ensure brevity in your answer.  0.11. What is the difference between the highest and the lowest Female students (as % of total students) in Moldova?
Give a very brief answer. 0.45. What is the difference between the highest and the lowest Female students (as % of total students) in Russian Federation?
Keep it short and to the point. 0.32. What is the difference between the highest and the lowest Female students (as % of total students) of Togo?
Your response must be concise. 2.68. What is the difference between the highest and the lowest Female students (as % of total students) of Zambia?
Your response must be concise. 1.56. 